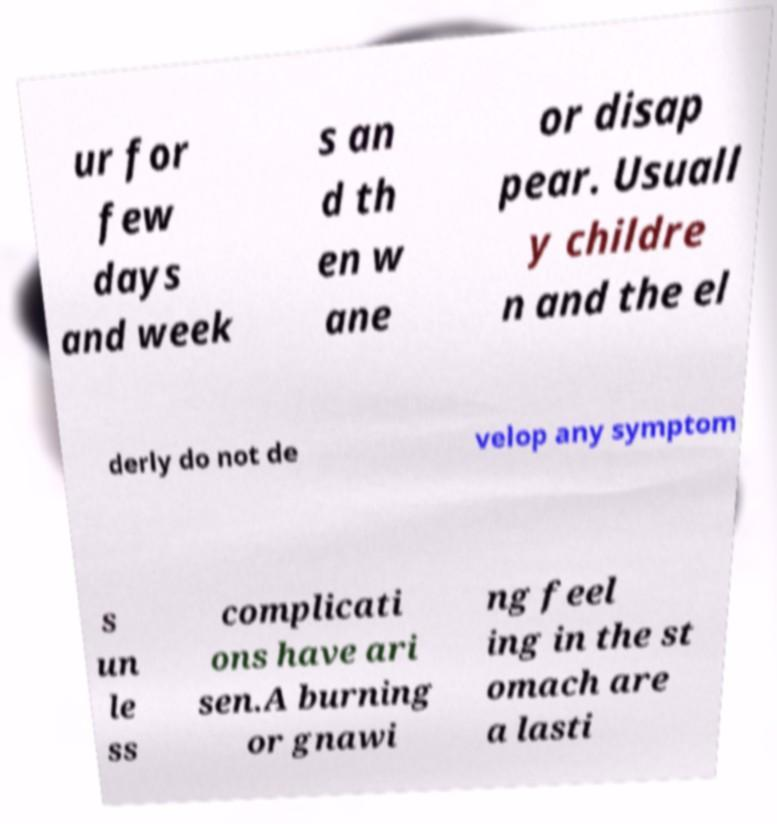There's text embedded in this image that I need extracted. Can you transcribe it verbatim? ur for few days and week s an d th en w ane or disap pear. Usuall y childre n and the el derly do not de velop any symptom s un le ss complicati ons have ari sen.A burning or gnawi ng feel ing in the st omach are a lasti 